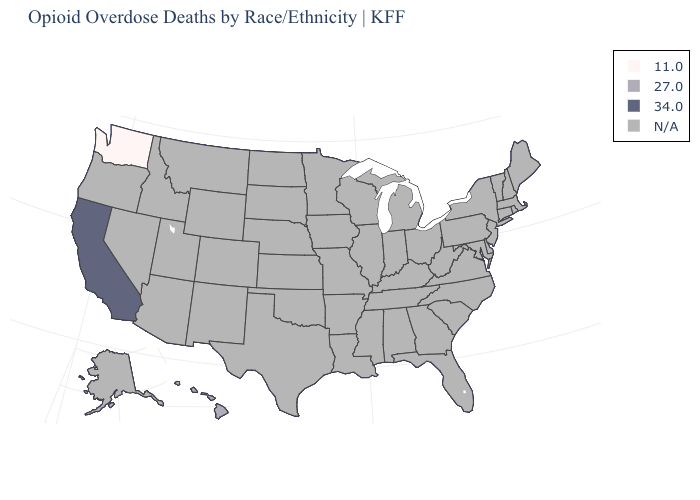What is the highest value in the West ?
Give a very brief answer. 34.0. Name the states that have a value in the range 11.0?
Concise answer only. Washington. Name the states that have a value in the range 34.0?
Be succinct. California. Does Washington have the lowest value in the USA?
Keep it brief. Yes. What is the value of Utah?
Quick response, please. N/A. Name the states that have a value in the range 11.0?
Concise answer only. Washington. What is the lowest value in the USA?
Short answer required. 11.0. Name the states that have a value in the range 34.0?
Concise answer only. California. Is the legend a continuous bar?
Answer briefly. No. Is the legend a continuous bar?
Be succinct. No. Which states have the highest value in the USA?
Concise answer only. California. Name the states that have a value in the range 11.0?
Be succinct. Washington. Does the map have missing data?
Give a very brief answer. Yes. What is the value of Oregon?
Write a very short answer. N/A. 